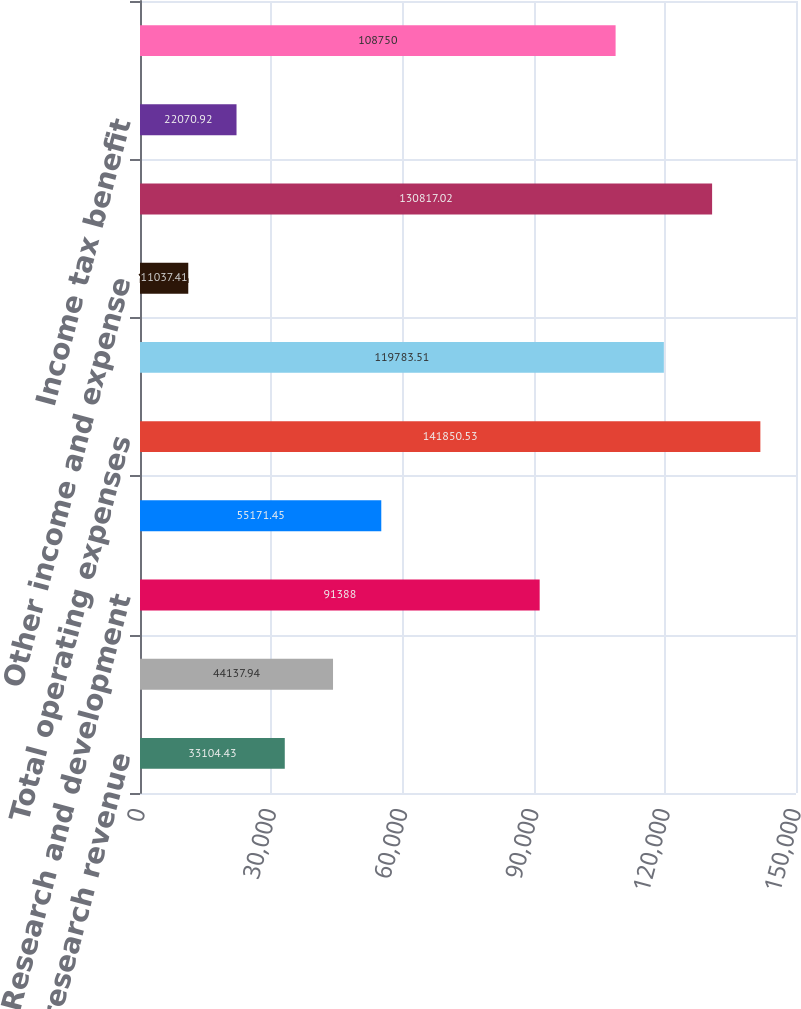<chart> <loc_0><loc_0><loc_500><loc_500><bar_chart><fcel>Contract research revenue<fcel>Total revenues<fcel>Research and development<fcel>Selling general and<fcel>Total operating expenses<fcel>Operating loss<fcel>Other income and expense<fcel>Loss before income tax benefit<fcel>Income tax benefit<fcel>Net loss<nl><fcel>33104.4<fcel>44137.9<fcel>91388<fcel>55171.4<fcel>141851<fcel>119784<fcel>11037.4<fcel>130817<fcel>22070.9<fcel>108750<nl></chart> 